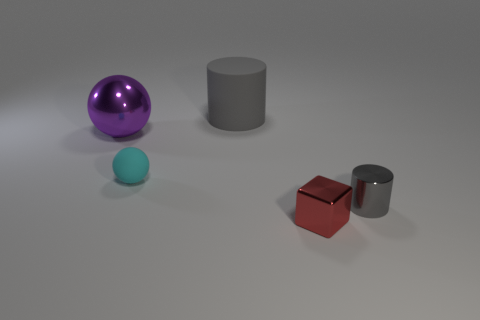Is the color of the large rubber thing the same as the cylinder that is in front of the tiny matte sphere?
Give a very brief answer. Yes. Is the shape of the small shiny object that is in front of the metallic cylinder the same as the metallic object behind the tiny gray object?
Provide a succinct answer. No. What is the color of the object in front of the metal thing that is on the right side of the thing in front of the shiny cylinder?
Keep it short and to the point. Red. What number of other objects are the same color as the big rubber object?
Your answer should be very brief. 1. Are there fewer small gray rubber cylinders than small red objects?
Give a very brief answer. Yes. There is a tiny object that is left of the gray shiny cylinder and right of the small cyan sphere; what color is it?
Your answer should be compact. Red. What is the material of the large object that is the same shape as the small cyan object?
Offer a very short reply. Metal. Is there anything else that is the same size as the matte sphere?
Ensure brevity in your answer.  Yes. Is the number of cyan rubber objects greater than the number of big green balls?
Make the answer very short. Yes. There is a thing that is both to the left of the big gray object and behind the small matte thing; how big is it?
Your answer should be very brief. Large. 